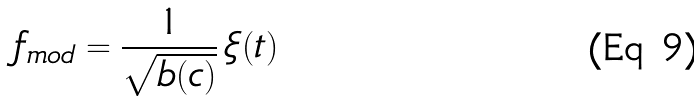<formula> <loc_0><loc_0><loc_500><loc_500>f _ { m o d } = \frac { 1 } { \sqrt { b ( c ) } } \, \xi ( t )</formula> 